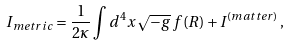<formula> <loc_0><loc_0><loc_500><loc_500>I _ { m e t r i c } = \frac { 1 } { 2 \kappa } \int d ^ { 4 } x \, \sqrt { - g } \, f ( R ) + I ^ { ( m a t t e r ) } \, ,</formula> 